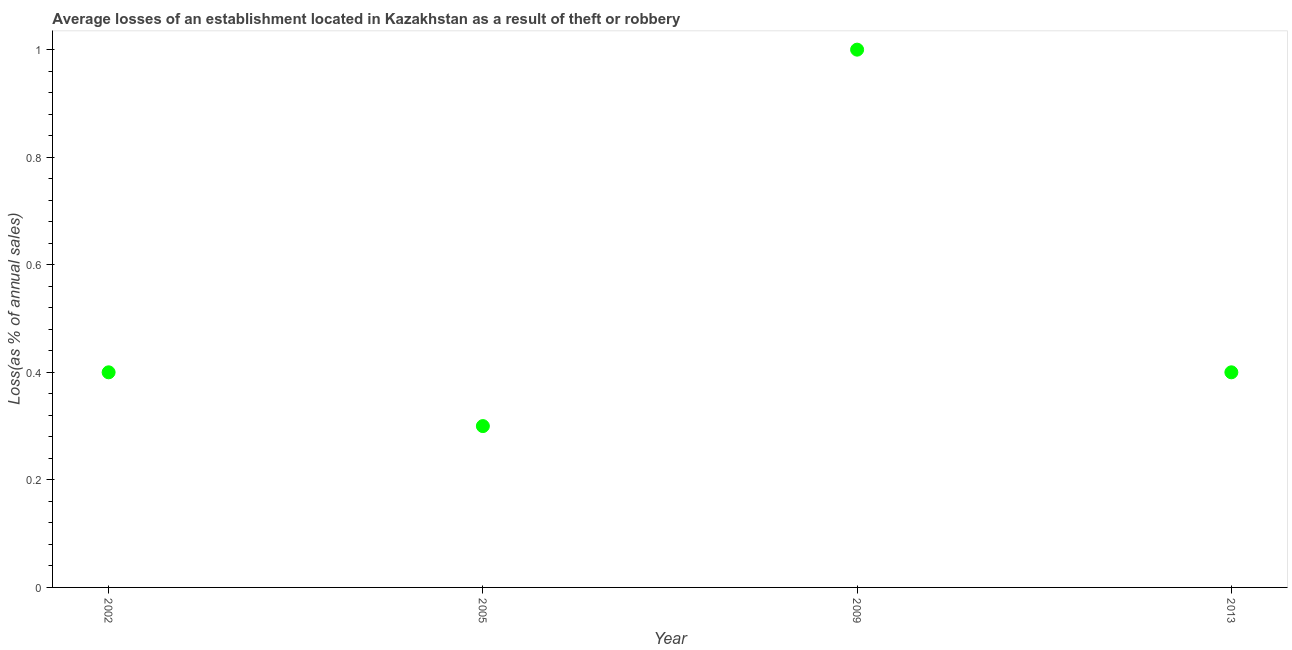Across all years, what is the maximum losses due to theft?
Keep it short and to the point. 1. In which year was the losses due to theft minimum?
Provide a short and direct response. 2005. What is the sum of the losses due to theft?
Offer a very short reply. 2.1. What is the difference between the losses due to theft in 2009 and 2013?
Keep it short and to the point. 0.6. What is the average losses due to theft per year?
Keep it short and to the point. 0.53. What is the median losses due to theft?
Offer a terse response. 0.4. Do a majority of the years between 2013 and 2005 (inclusive) have losses due to theft greater than 0.56 %?
Make the answer very short. No. What is the ratio of the losses due to theft in 2005 to that in 2009?
Keep it short and to the point. 0.3. What is the difference between the highest and the second highest losses due to theft?
Make the answer very short. 0.6. What is the difference between the highest and the lowest losses due to theft?
Give a very brief answer. 0.7. In how many years, is the losses due to theft greater than the average losses due to theft taken over all years?
Your answer should be compact. 1. How many years are there in the graph?
Give a very brief answer. 4. What is the difference between two consecutive major ticks on the Y-axis?
Provide a short and direct response. 0.2. What is the title of the graph?
Give a very brief answer. Average losses of an establishment located in Kazakhstan as a result of theft or robbery. What is the label or title of the Y-axis?
Offer a terse response. Loss(as % of annual sales). What is the Loss(as % of annual sales) in 2002?
Offer a terse response. 0.4. What is the difference between the Loss(as % of annual sales) in 2002 and 2005?
Offer a terse response. 0.1. What is the difference between the Loss(as % of annual sales) in 2002 and 2009?
Provide a short and direct response. -0.6. What is the difference between the Loss(as % of annual sales) in 2005 and 2009?
Offer a very short reply. -0.7. What is the ratio of the Loss(as % of annual sales) in 2002 to that in 2005?
Your answer should be very brief. 1.33. What is the ratio of the Loss(as % of annual sales) in 2002 to that in 2009?
Ensure brevity in your answer.  0.4. What is the ratio of the Loss(as % of annual sales) in 2005 to that in 2009?
Make the answer very short. 0.3. What is the ratio of the Loss(as % of annual sales) in 2005 to that in 2013?
Provide a short and direct response. 0.75. 